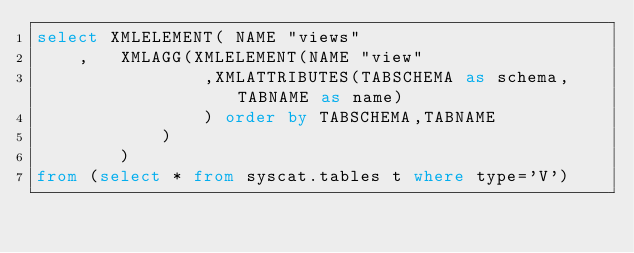<code> <loc_0><loc_0><loc_500><loc_500><_SQL_>select XMLELEMENT( NAME "views"
	,	XMLAGG(XMLELEMENT(NAME "view"
				,XMLATTRIBUTES(TABSCHEMA as schema,TABNAME as name)
				) order by TABSCHEMA,TABNAME
			)
		)
from (select * from syscat.tables t where type='V')</code> 